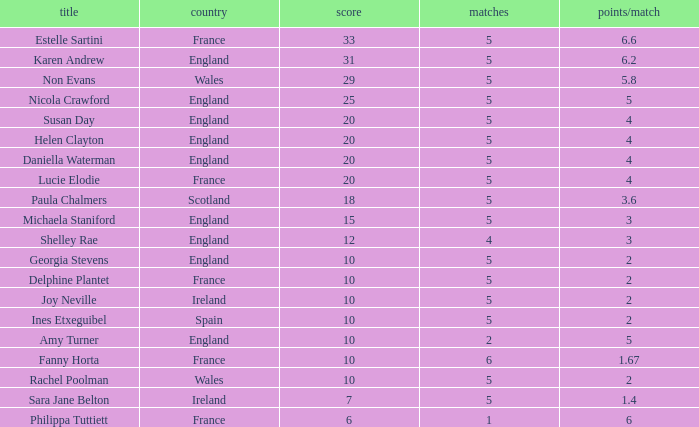Can you tell me the lowest Pts/game that has the Games larger than 6? None. 